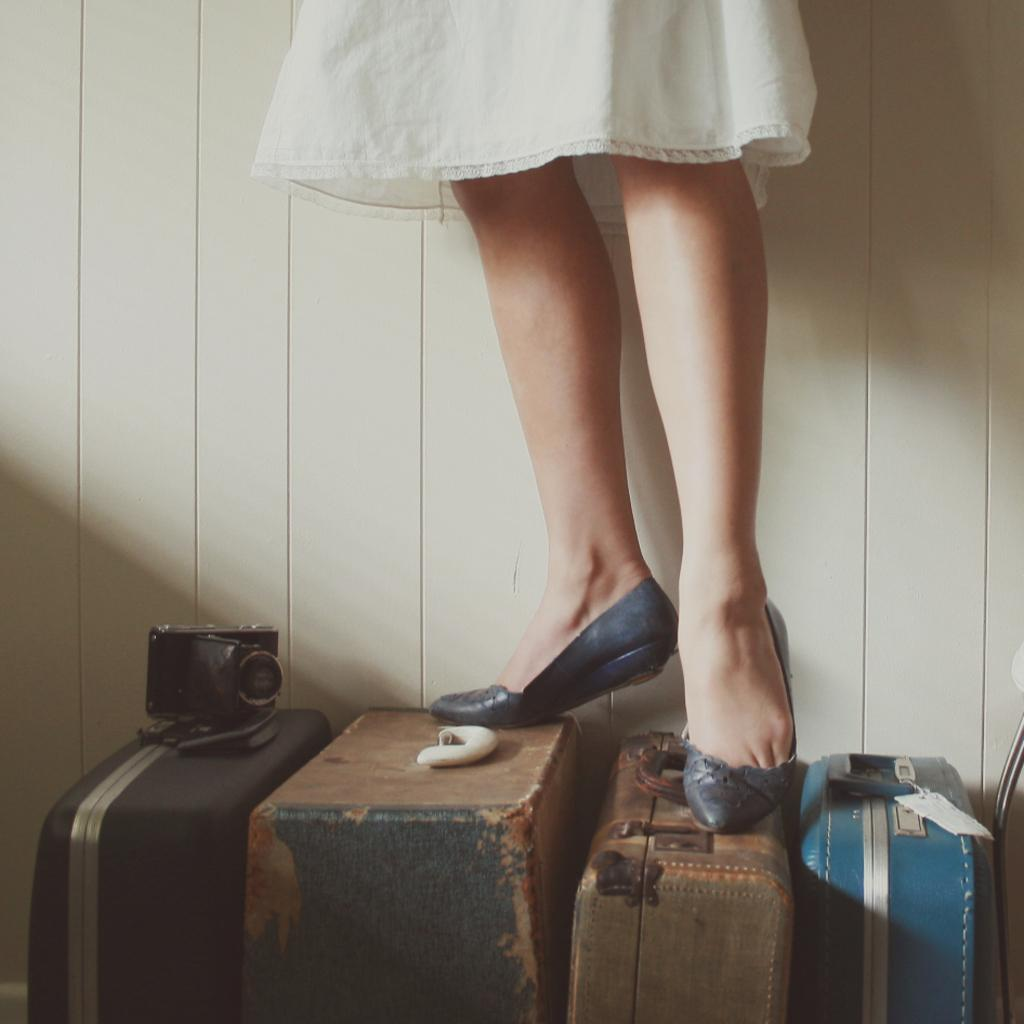Who is the main subject in the image? There is a woman in the image. What is the woman doing in the image? The woman is standing on a suitcase. Is there any additional object on the suitcase? Yes, there is a device on the suitcase. What type of rake is the woman using to fight with in the image? There is no rake present in the image, and the woman is not fighting with anyone. 